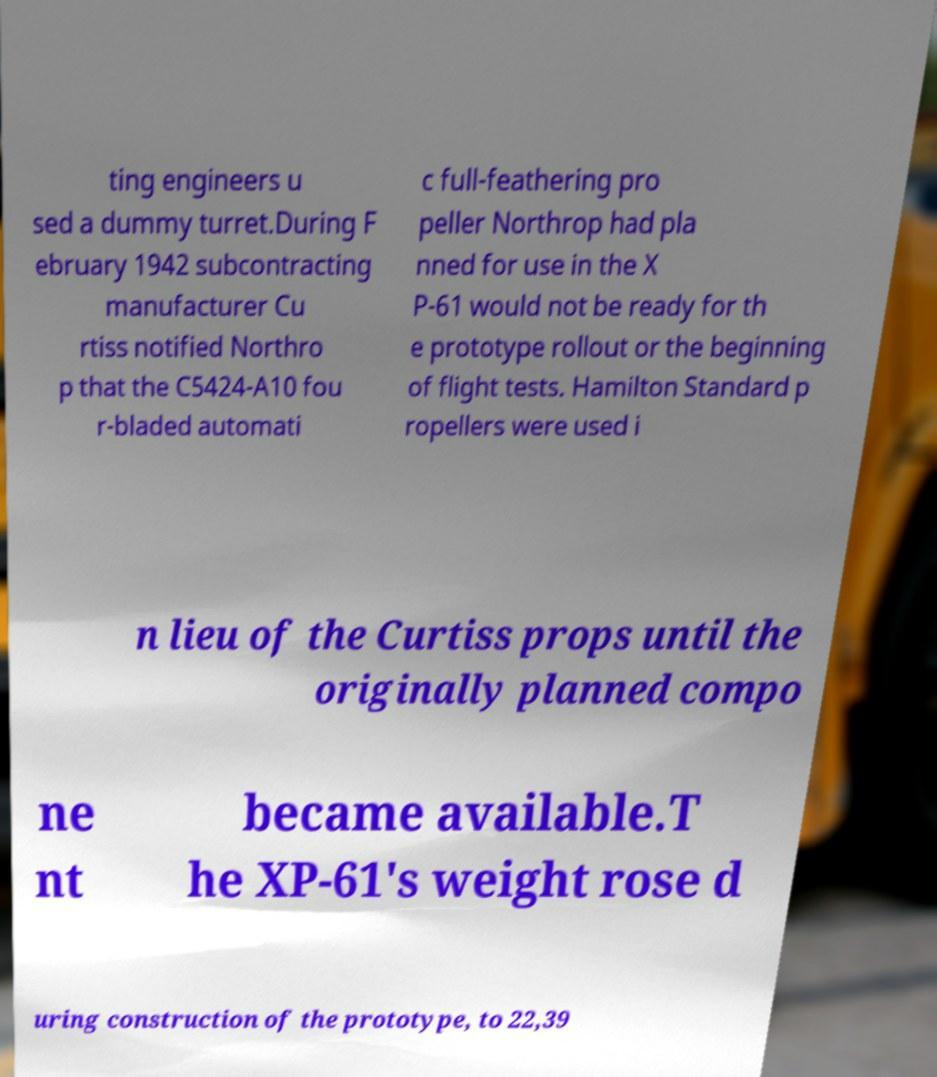Please read and relay the text visible in this image. What does it say? ting engineers u sed a dummy turret.During F ebruary 1942 subcontracting manufacturer Cu rtiss notified Northro p that the C5424-A10 fou r-bladed automati c full-feathering pro peller Northrop had pla nned for use in the X P-61 would not be ready for th e prototype rollout or the beginning of flight tests. Hamilton Standard p ropellers were used i n lieu of the Curtiss props until the originally planned compo ne nt became available.T he XP-61's weight rose d uring construction of the prototype, to 22,39 